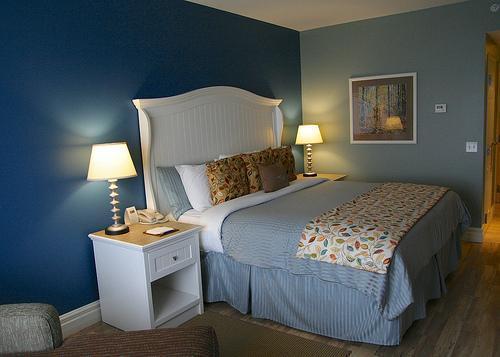How many lamps are in this room?
Give a very brief answer. 2. 